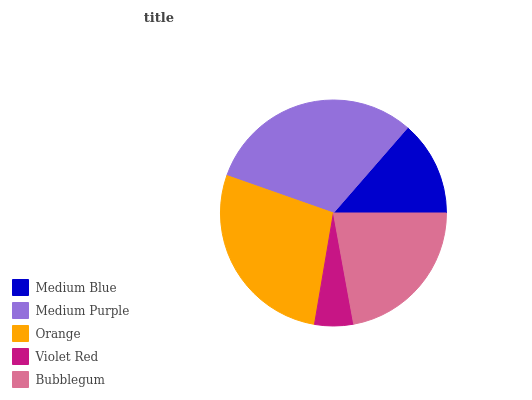Is Violet Red the minimum?
Answer yes or no. Yes. Is Medium Purple the maximum?
Answer yes or no. Yes. Is Orange the minimum?
Answer yes or no. No. Is Orange the maximum?
Answer yes or no. No. Is Medium Purple greater than Orange?
Answer yes or no. Yes. Is Orange less than Medium Purple?
Answer yes or no. Yes. Is Orange greater than Medium Purple?
Answer yes or no. No. Is Medium Purple less than Orange?
Answer yes or no. No. Is Bubblegum the high median?
Answer yes or no. Yes. Is Bubblegum the low median?
Answer yes or no. Yes. Is Medium Purple the high median?
Answer yes or no. No. Is Medium Purple the low median?
Answer yes or no. No. 